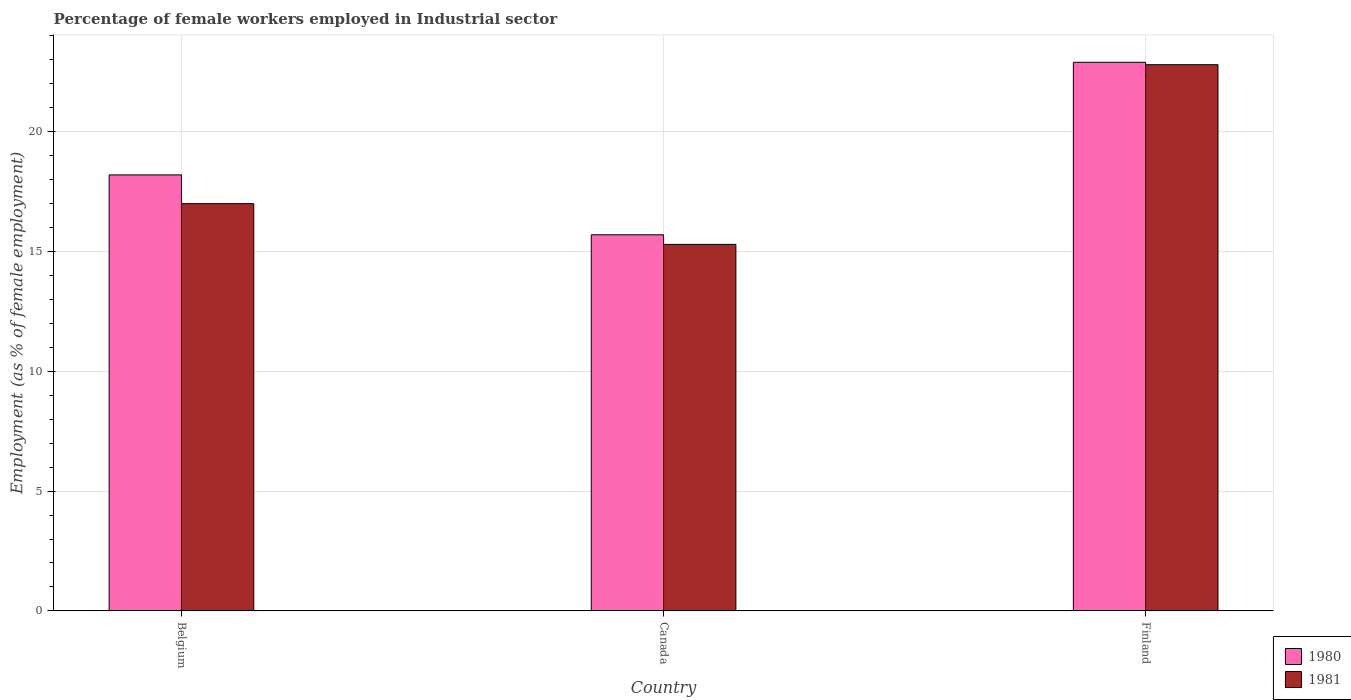Are the number of bars on each tick of the X-axis equal?
Your answer should be compact. Yes. How many bars are there on the 3rd tick from the left?
Your answer should be very brief. 2. What is the label of the 1st group of bars from the left?
Ensure brevity in your answer.  Belgium. Across all countries, what is the maximum percentage of females employed in Industrial sector in 1981?
Offer a terse response. 22.8. Across all countries, what is the minimum percentage of females employed in Industrial sector in 1980?
Offer a terse response. 15.7. In which country was the percentage of females employed in Industrial sector in 1981 minimum?
Your answer should be compact. Canada. What is the total percentage of females employed in Industrial sector in 1981 in the graph?
Offer a very short reply. 55.1. What is the difference between the percentage of females employed in Industrial sector in 1980 in Canada and that in Finland?
Provide a succinct answer. -7.2. What is the difference between the percentage of females employed in Industrial sector in 1981 in Canada and the percentage of females employed in Industrial sector in 1980 in Belgium?
Provide a short and direct response. -2.9. What is the average percentage of females employed in Industrial sector in 1981 per country?
Provide a short and direct response. 18.37. What is the difference between the percentage of females employed in Industrial sector of/in 1981 and percentage of females employed in Industrial sector of/in 1980 in Canada?
Make the answer very short. -0.4. In how many countries, is the percentage of females employed in Industrial sector in 1981 greater than 7 %?
Ensure brevity in your answer.  3. What is the ratio of the percentage of females employed in Industrial sector in 1981 in Belgium to that in Canada?
Provide a succinct answer. 1.11. What is the difference between the highest and the second highest percentage of females employed in Industrial sector in 1981?
Offer a terse response. -5.8. What is the difference between the highest and the lowest percentage of females employed in Industrial sector in 1981?
Your answer should be very brief. 7.5. What does the 2nd bar from the left in Belgium represents?
Ensure brevity in your answer.  1981. How many bars are there?
Offer a very short reply. 6. Are all the bars in the graph horizontal?
Your answer should be compact. No. What is the difference between two consecutive major ticks on the Y-axis?
Your answer should be very brief. 5. Does the graph contain any zero values?
Keep it short and to the point. No. How many legend labels are there?
Offer a terse response. 2. How are the legend labels stacked?
Provide a succinct answer. Vertical. What is the title of the graph?
Your response must be concise. Percentage of female workers employed in Industrial sector. Does "1992" appear as one of the legend labels in the graph?
Keep it short and to the point. No. What is the label or title of the Y-axis?
Give a very brief answer. Employment (as % of female employment). What is the Employment (as % of female employment) of 1980 in Belgium?
Provide a short and direct response. 18.2. What is the Employment (as % of female employment) in 1981 in Belgium?
Keep it short and to the point. 17. What is the Employment (as % of female employment) in 1980 in Canada?
Make the answer very short. 15.7. What is the Employment (as % of female employment) of 1981 in Canada?
Your response must be concise. 15.3. What is the Employment (as % of female employment) of 1980 in Finland?
Your answer should be compact. 22.9. What is the Employment (as % of female employment) of 1981 in Finland?
Keep it short and to the point. 22.8. Across all countries, what is the maximum Employment (as % of female employment) in 1980?
Your answer should be very brief. 22.9. Across all countries, what is the maximum Employment (as % of female employment) in 1981?
Keep it short and to the point. 22.8. Across all countries, what is the minimum Employment (as % of female employment) in 1980?
Your answer should be very brief. 15.7. Across all countries, what is the minimum Employment (as % of female employment) of 1981?
Your answer should be compact. 15.3. What is the total Employment (as % of female employment) in 1980 in the graph?
Offer a very short reply. 56.8. What is the total Employment (as % of female employment) in 1981 in the graph?
Provide a succinct answer. 55.1. What is the difference between the Employment (as % of female employment) of 1980 in Belgium and that in Finland?
Offer a very short reply. -4.7. What is the difference between the Employment (as % of female employment) of 1981 in Canada and that in Finland?
Give a very brief answer. -7.5. What is the average Employment (as % of female employment) of 1980 per country?
Your answer should be very brief. 18.93. What is the average Employment (as % of female employment) of 1981 per country?
Keep it short and to the point. 18.37. What is the difference between the Employment (as % of female employment) in 1980 and Employment (as % of female employment) in 1981 in Canada?
Your answer should be very brief. 0.4. What is the ratio of the Employment (as % of female employment) of 1980 in Belgium to that in Canada?
Your answer should be compact. 1.16. What is the ratio of the Employment (as % of female employment) in 1981 in Belgium to that in Canada?
Make the answer very short. 1.11. What is the ratio of the Employment (as % of female employment) of 1980 in Belgium to that in Finland?
Keep it short and to the point. 0.79. What is the ratio of the Employment (as % of female employment) of 1981 in Belgium to that in Finland?
Your response must be concise. 0.75. What is the ratio of the Employment (as % of female employment) in 1980 in Canada to that in Finland?
Provide a succinct answer. 0.69. What is the ratio of the Employment (as % of female employment) of 1981 in Canada to that in Finland?
Your response must be concise. 0.67. What is the difference between the highest and the lowest Employment (as % of female employment) in 1980?
Keep it short and to the point. 7.2. What is the difference between the highest and the lowest Employment (as % of female employment) in 1981?
Your answer should be compact. 7.5. 